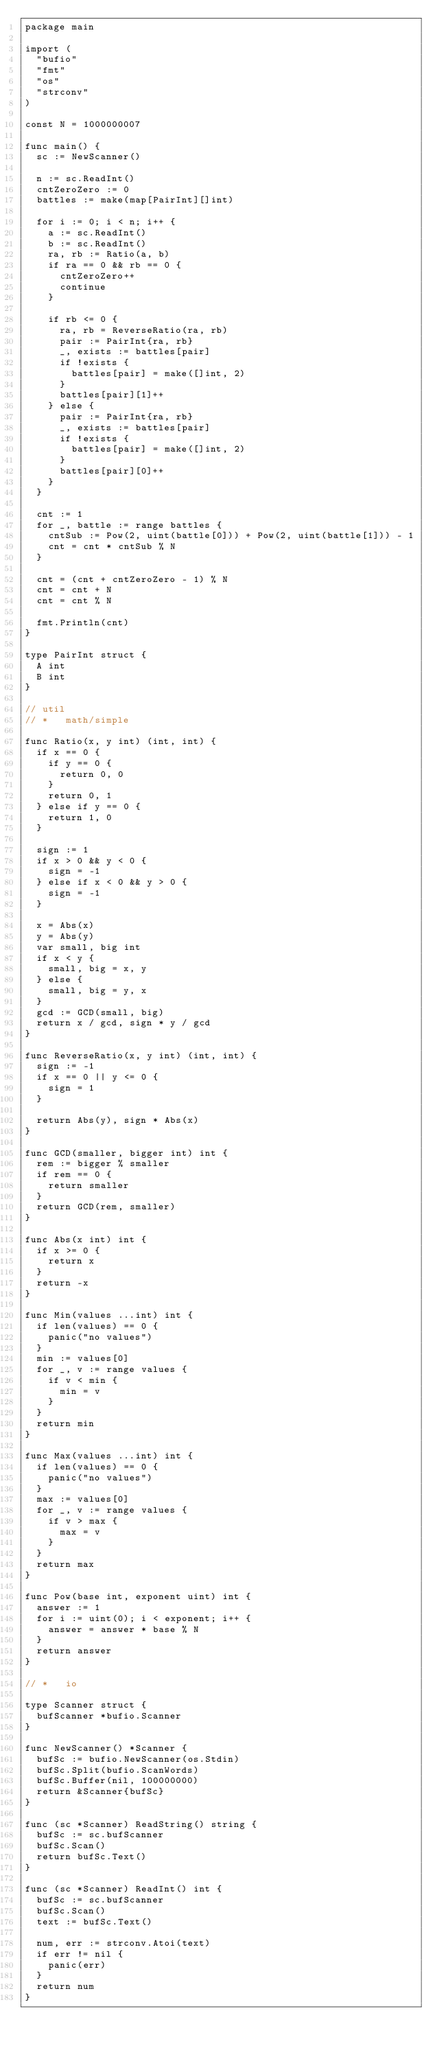Convert code to text. <code><loc_0><loc_0><loc_500><loc_500><_Go_>package main

import (
	"bufio"
	"fmt"
	"os"
	"strconv"
)

const N = 1000000007

func main() {
	sc := NewScanner()

	n := sc.ReadInt()
	cntZeroZero := 0
	battles := make(map[PairInt][]int)

	for i := 0; i < n; i++ {
		a := sc.ReadInt()
		b := sc.ReadInt()
		ra, rb := Ratio(a, b)
		if ra == 0 && rb == 0 {
			cntZeroZero++
			continue
		}

		if rb <= 0 {
			ra, rb = ReverseRatio(ra, rb)
			pair := PairInt{ra, rb}
			_, exists := battles[pair]
			if !exists {
				battles[pair] = make([]int, 2)
			}
			battles[pair][1]++
		} else {
			pair := PairInt{ra, rb}
			_, exists := battles[pair]
			if !exists {
				battles[pair] = make([]int, 2)
			}
			battles[pair][0]++
		}
	}

	cnt := 1
	for _, battle := range battles {
		cntSub := Pow(2, uint(battle[0])) + Pow(2, uint(battle[1])) - 1
		cnt = cnt * cntSub % N
	}

	cnt = (cnt + cntZeroZero - 1) % N
	cnt = cnt + N
	cnt = cnt % N

	fmt.Println(cnt)
}

type PairInt struct {
	A int
	B int
}

// util
// *   math/simple

func Ratio(x, y int) (int, int) {
	if x == 0 {
		if y == 0 {
			return 0, 0
		}
		return 0, 1
	} else if y == 0 {
		return 1, 0
	}

	sign := 1
	if x > 0 && y < 0 {
		sign = -1
	} else if x < 0 && y > 0 {
		sign = -1
	}

	x = Abs(x)
	y = Abs(y)
	var small, big int
	if x < y {
		small, big = x, y
	} else {
		small, big = y, x
	}
	gcd := GCD(small, big)
	return x / gcd, sign * y / gcd
}

func ReverseRatio(x, y int) (int, int) {
	sign := -1
	if x == 0 || y <= 0 {
		sign = 1
	}

	return Abs(y), sign * Abs(x)
}

func GCD(smaller, bigger int) int {
	rem := bigger % smaller
	if rem == 0 {
		return smaller
	}
	return GCD(rem, smaller)
}

func Abs(x int) int {
	if x >= 0 {
		return x
	}
	return -x
}

func Min(values ...int) int {
	if len(values) == 0 {
		panic("no values")
	}
	min := values[0]
	for _, v := range values {
		if v < min {
			min = v
		}
	}
	return min
}

func Max(values ...int) int {
	if len(values) == 0 {
		panic("no values")
	}
	max := values[0]
	for _, v := range values {
		if v > max {
			max = v
		}
	}
	return max
}

func Pow(base int, exponent uint) int {
	answer := 1
	for i := uint(0); i < exponent; i++ {
		answer = answer * base % N
	}
	return answer
}

// *   io

type Scanner struct {
	bufScanner *bufio.Scanner
}

func NewScanner() *Scanner {
	bufSc := bufio.NewScanner(os.Stdin)
	bufSc.Split(bufio.ScanWords)
	bufSc.Buffer(nil, 100000000)
	return &Scanner{bufSc}
}

func (sc *Scanner) ReadString() string {
	bufSc := sc.bufScanner
	bufSc.Scan()
	return bufSc.Text()
}

func (sc *Scanner) ReadInt() int {
	bufSc := sc.bufScanner
	bufSc.Scan()
	text := bufSc.Text()

	num, err := strconv.Atoi(text)
	if err != nil {
		panic(err)
	}
	return num
}
</code> 